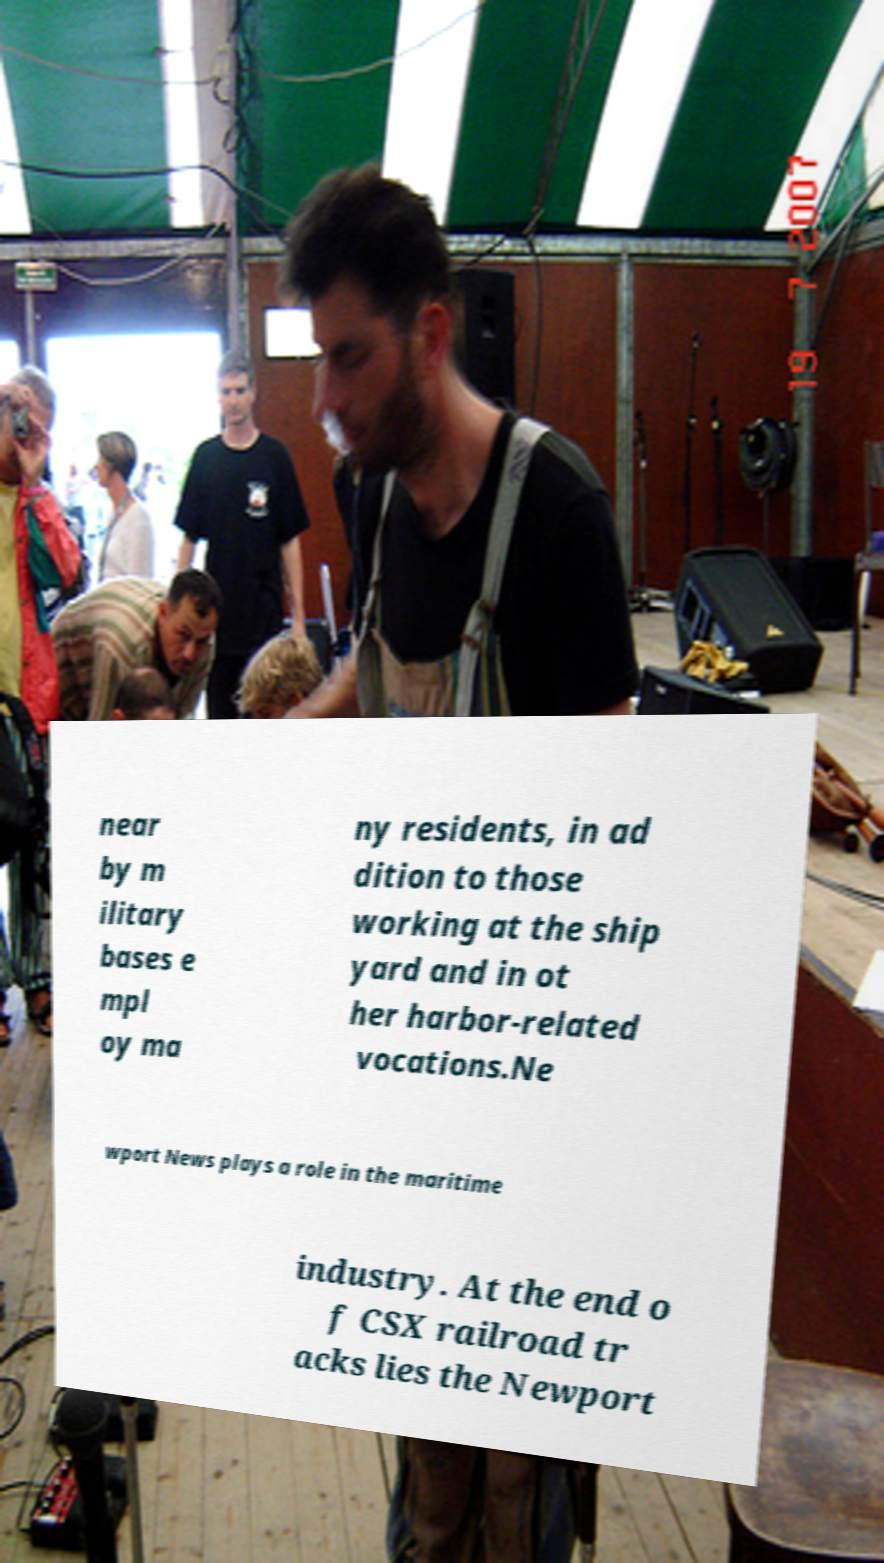Please read and relay the text visible in this image. What does it say? near by m ilitary bases e mpl oy ma ny residents, in ad dition to those working at the ship yard and in ot her harbor-related vocations.Ne wport News plays a role in the maritime industry. At the end o f CSX railroad tr acks lies the Newport 